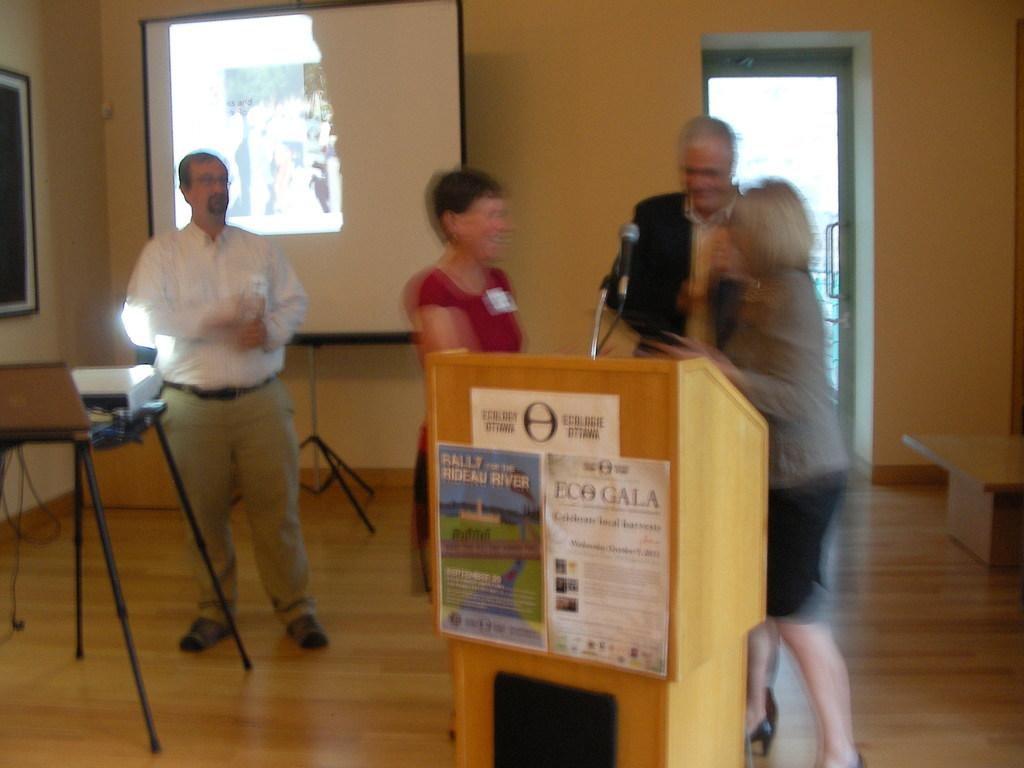How many people are standing in the image? There are four persons standing on the floor in the image. What can be seen in the image that might be used for presentations? There is a podium, a table, a projector, and posters in the image. What is the purpose of the frame in the image? The frame in the image is likely used to hold or display the posters. What is the background of the image composed of? The background of the image includes a door, a wall, and possibly other elements. What type of mist can be seen in the image? There is no mist present in the image; it is an indoor setting with a door, a wall, and various objects and elements. 